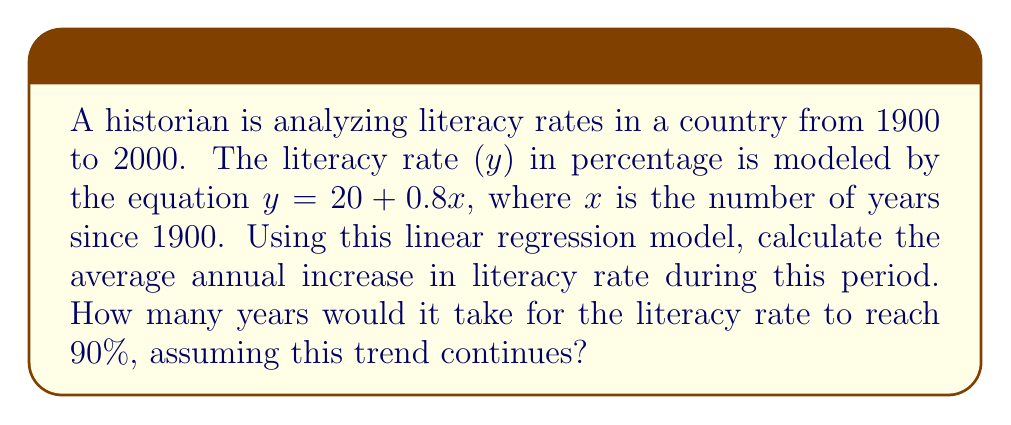Solve this math problem. 1. Interpret the linear regression model:
   $y = 20 + 0.8x$
   where y is the literacy rate (%) and x is years since 1900.

2. The slope of the line, 0.8, represents the average annual increase in literacy rate.

3. To find when the literacy rate reaches 90%, solve the equation:
   $90 = 20 + 0.8x$
   $70 = 0.8x$
   $x = 70 / 0.8 = 87.5$ years

4. Since x represents years since 1900, add 1900 to get the actual year:
   1900 + 87.5 = 1987.5

5. Round to the nearest year: 1988

Thus, it would take until 1988, or 88 years from 1900, for the literacy rate to reach 90%.
Answer: 0.8% per year; 88 years 